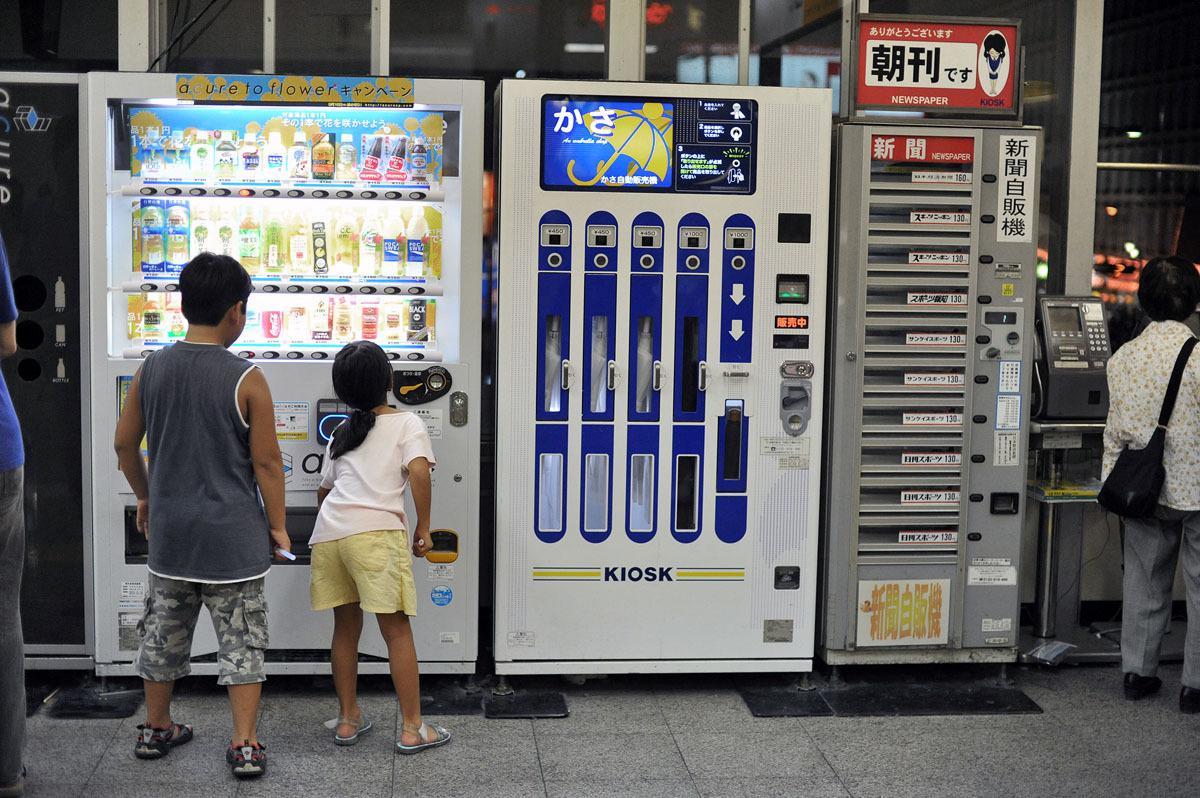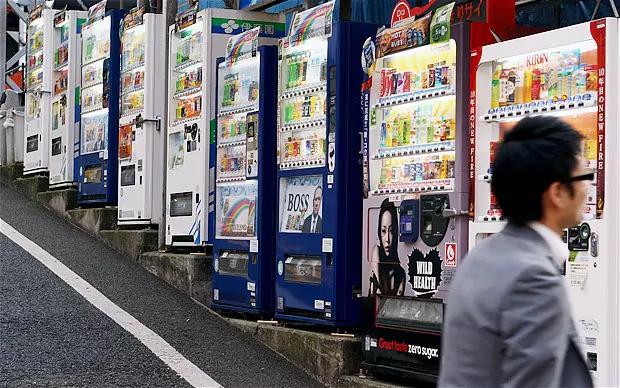The first image is the image on the left, the second image is the image on the right. For the images shown, is this caption "The left image has a food vending machine, the right image has a beverage vending machine." true? Answer yes or no. No. The first image is the image on the left, the second image is the image on the right. Considering the images on both sides, is "One photo shows a white vending machine that clearly offers food rather than beverages." valid? Answer yes or no. No. 